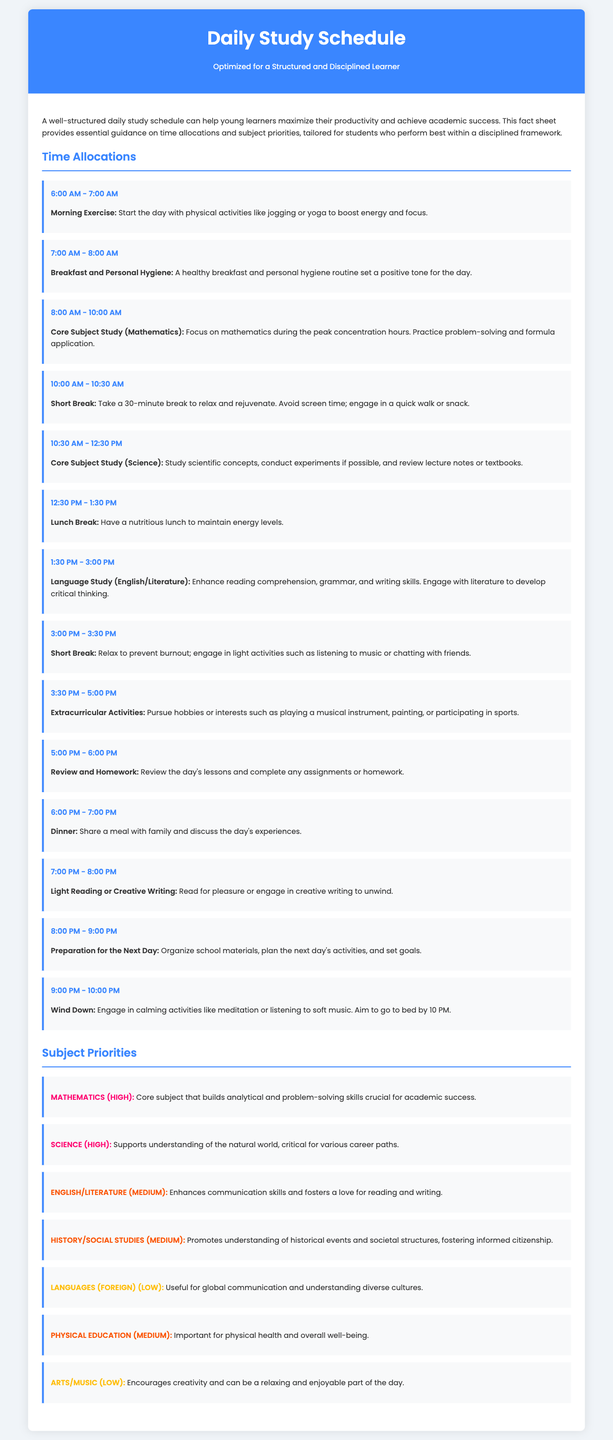What time is allocated for breakfast? The time allocated for breakfast is clearly stated in the schedule as 7:00 AM - 8:00 AM.
Answer: 7:00 AM - 8:00 AM What is the first activity of the day? The schedule lists "Morning Exercise" as the first activity from 6:00 AM to 7:00 AM.
Answer: Morning Exercise Which subject has the highest priority? The subject with the highest priority mentioned in the document is Mathematics, categorized as high priority.
Answer: Mathematics How long is the lunch break? The document indicates that the lunch break lasts for 1 hour, from 12:30 PM to 1:30 PM.
Answer: 1 hour What activity follows the core subject study of Science? According to the schedule, the activity that follows the Science study is the lunch break.
Answer: Lunch Break What is the scheduled time for light reading or creative writing? The document specifies that light reading or creative writing takes place from 7:00 PM to 8:00 PM.
Answer: 7:00 PM - 8:00 PM How many hours are allocated for core subject study? The total time allocated for core subject study (Mathematics and Science) is 4 hours (2 hours each).
Answer: 4 hours Which activity is scheduled before dinner? The activity scheduled before dinner is "Review and Homework" from 5:00 PM to 6:00 PM.
Answer: Review and Homework What priority level is given to Foreign Languages? The document indicates that the priority level of Foreign Languages is categorized as low.
Answer: Low 